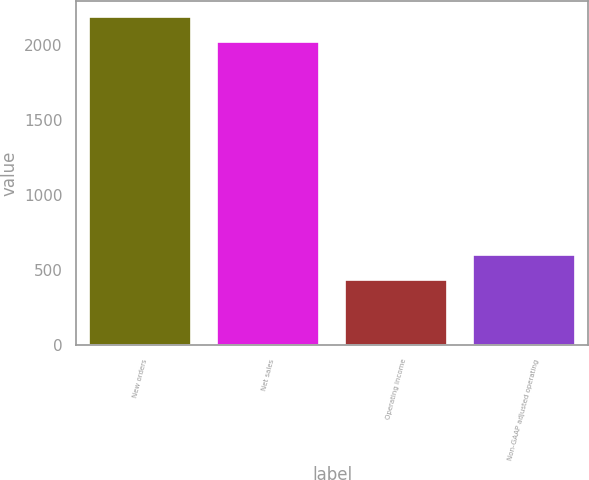<chart> <loc_0><loc_0><loc_500><loc_500><bar_chart><fcel>New orders<fcel>Net sales<fcel>Operating income<fcel>Non-GAAP adjusted operating<nl><fcel>2188.4<fcel>2023<fcel>436<fcel>601.4<nl></chart> 